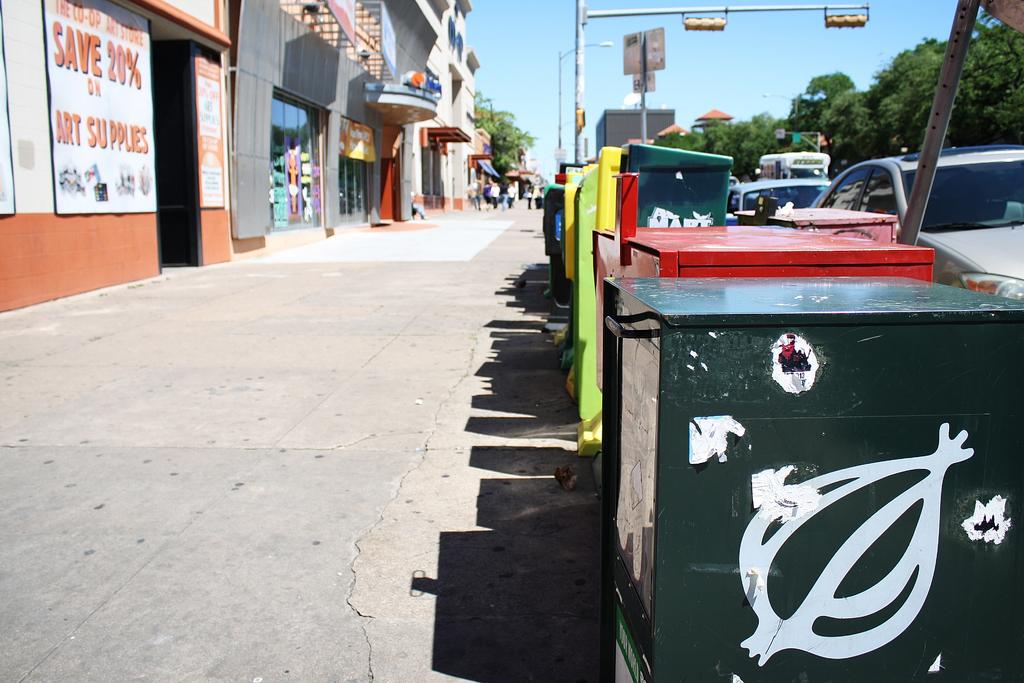How much can i save on art?
Provide a succinct answer. 20%. What are they selling?
Give a very brief answer. Art supplies. 